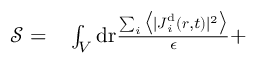Convert formula to latex. <formula><loc_0><loc_0><loc_500><loc_500>\begin{array} { r l } { { \mathcal { S } } = } & \int _ { V } d { r } \frac { \sum _ { i } \left \langle | { J } _ { i } ^ { d } ( { r } , t ) | ^ { 2 } \right \rangle } { \epsilon } + } \end{array}</formula> 